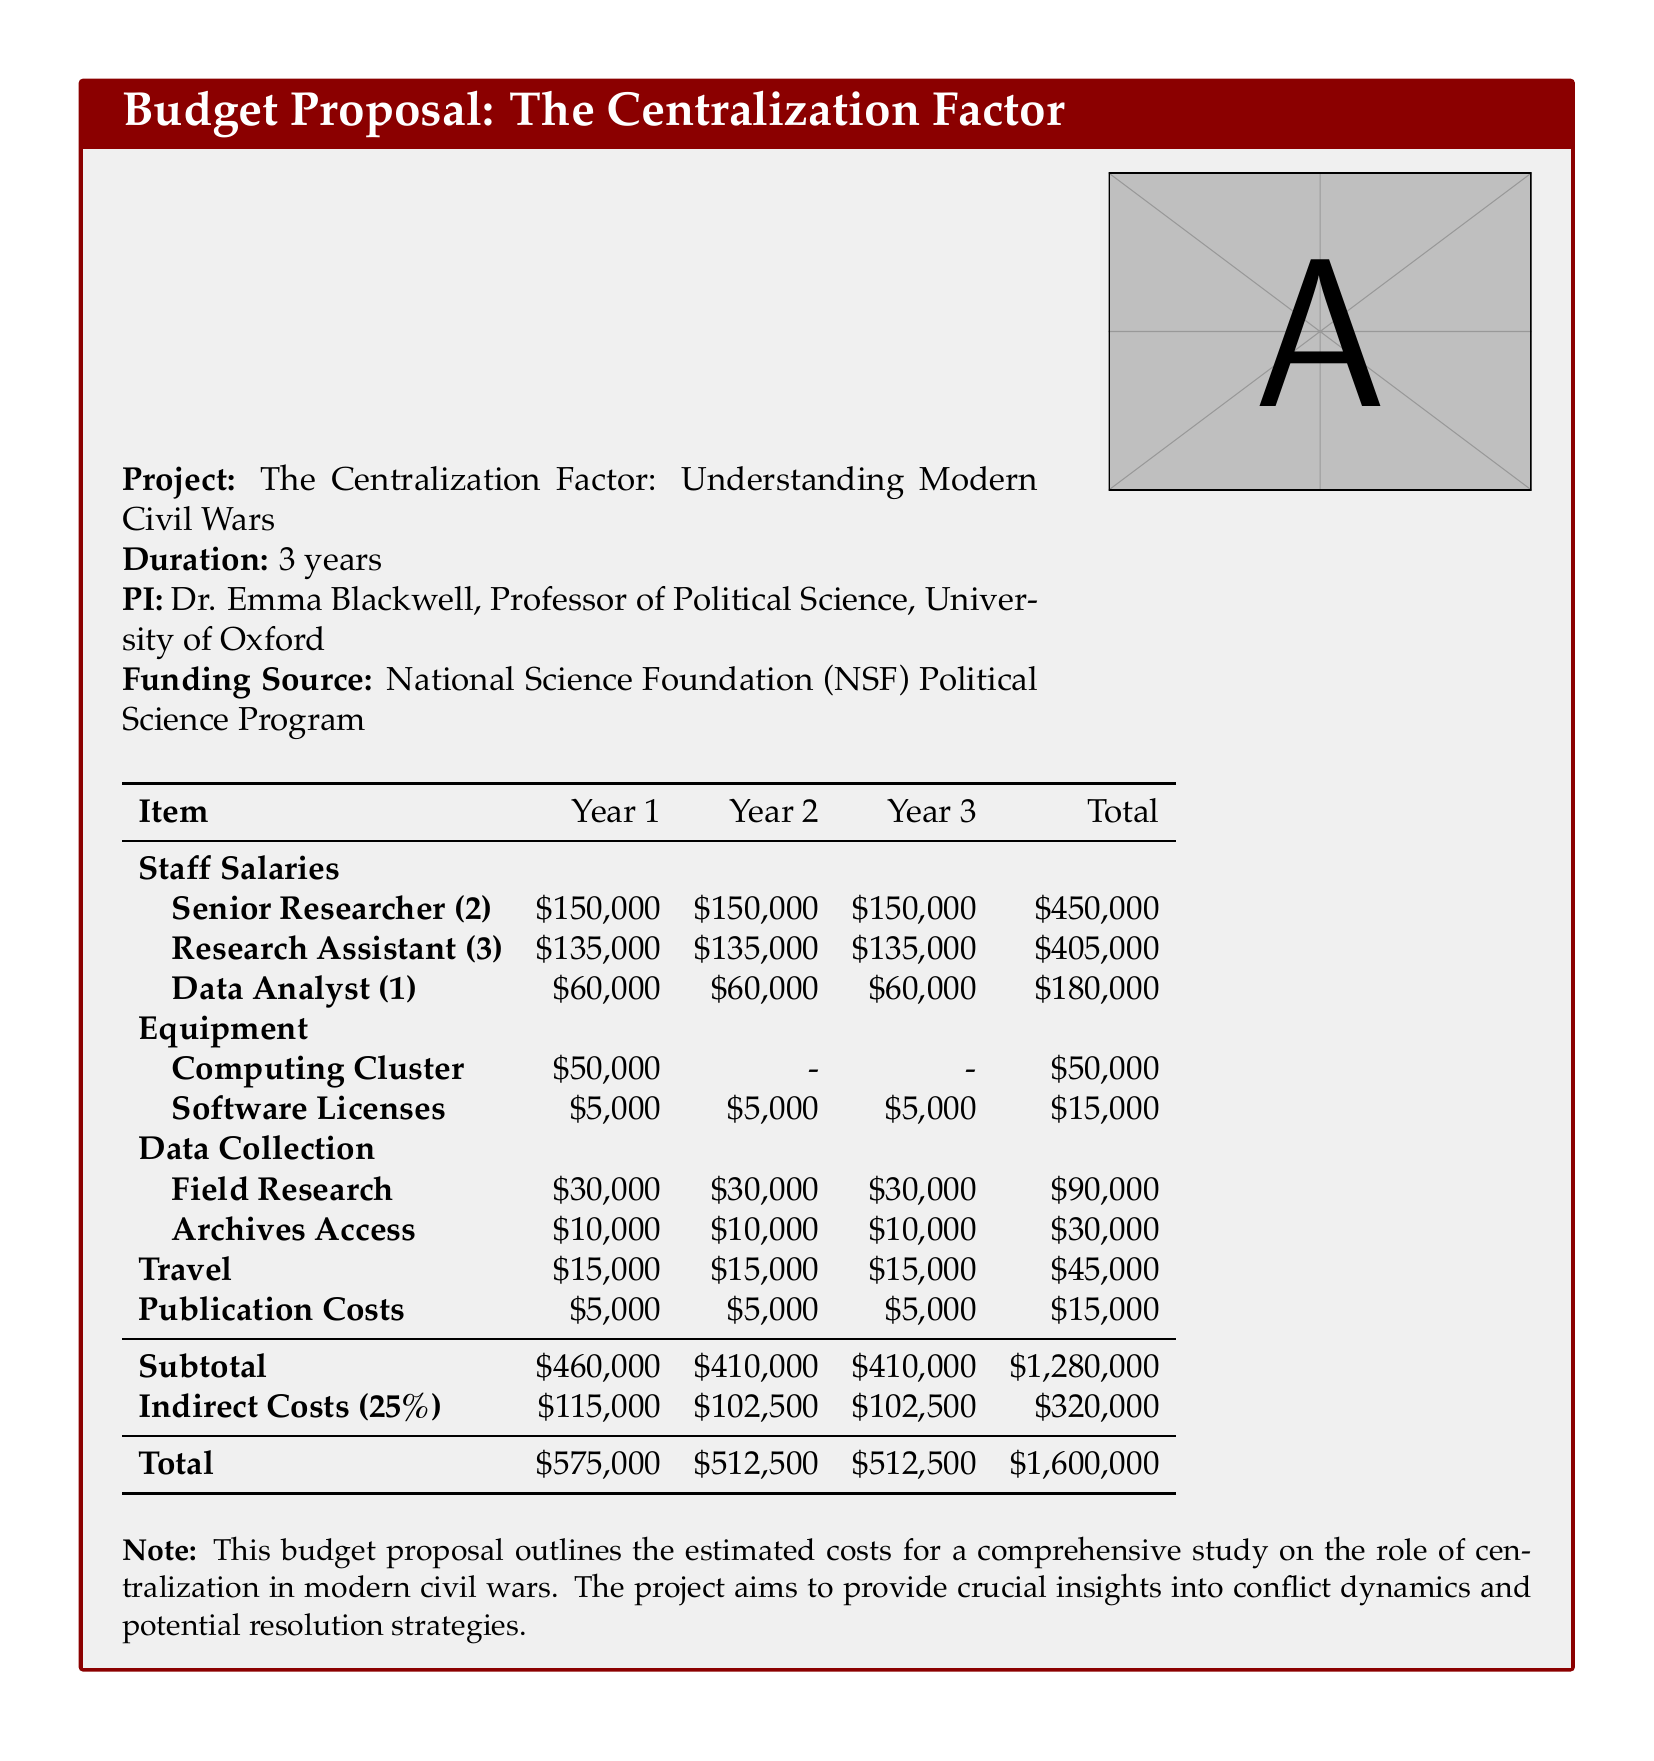What is the total budget for the project? The total budget is the sum of all costs over three years, which is detailed in the table.
Answer: $1,600,000 Who is the principal investigator (PI) of the project? The principal investigator is mentioned in the project details as Dr. Emma Blackwell.
Answer: Dr. Emma Blackwell How much is allocated for the computing cluster? The budget specifies a one-time cost for the computing cluster in Year 1 only.
Answer: $50,000 What is the total cost for staff salaries across all three years? The staff salaries are summed up from the detailed entries for each position and year.
Answer: $1,035,000 What are the indirect costs percentage mentioned in the document? The document explicitly states the indirect costs as a percentage of the subtotal.
Answer: 25% How many research assistants are included in the budget proposal? The document lists the number of research assistants along with their salaries.
Answer: 3 What is the budget for travel expenses each year? The travel expenses are consistent across the three years as stated in the budget.
Answer: $15,000 How much will the archives access cost in total? The total cost for archives access is the sum across all three years provided in the budget.
Answer: $30,000 What is the duration of the project? The document states the length of the project in its opening details.
Answer: 3 years 